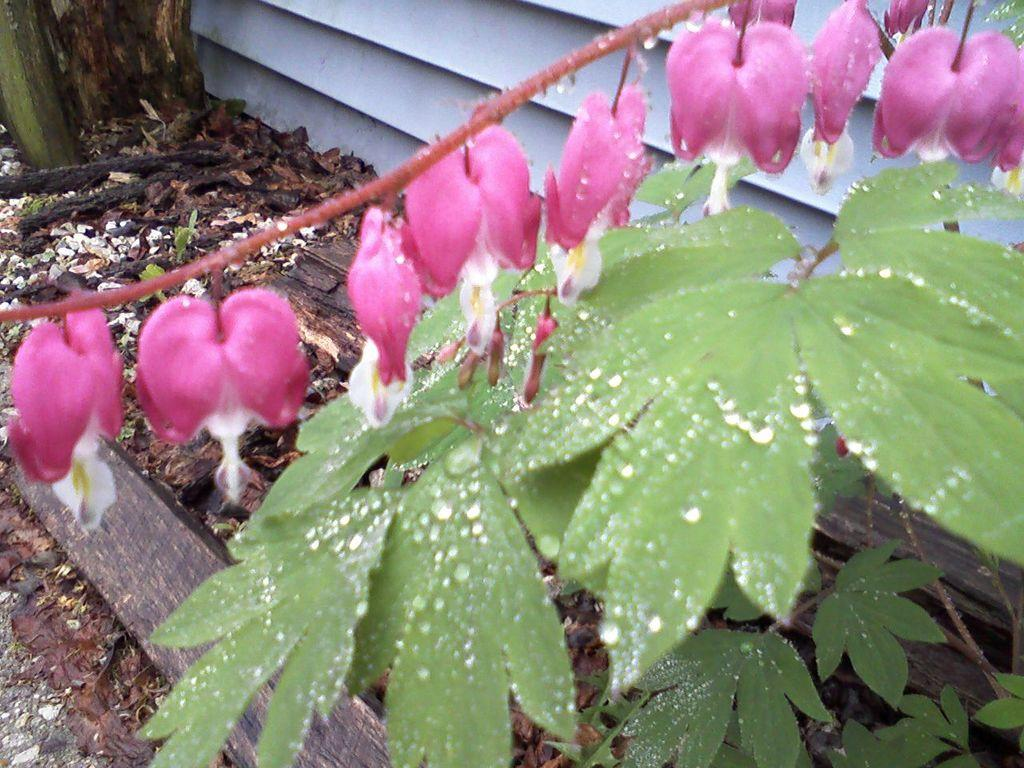What type of living organisms can be seen in the image? Plants and flowers are visible in the image. Can you describe the flowers in the image? The flowers in the image are part of the plants and add color and beauty to the scene. What type of music is the band playing in the background of the image? There is no band present in the image, so it is not possible to determine what type of music might be playing. 